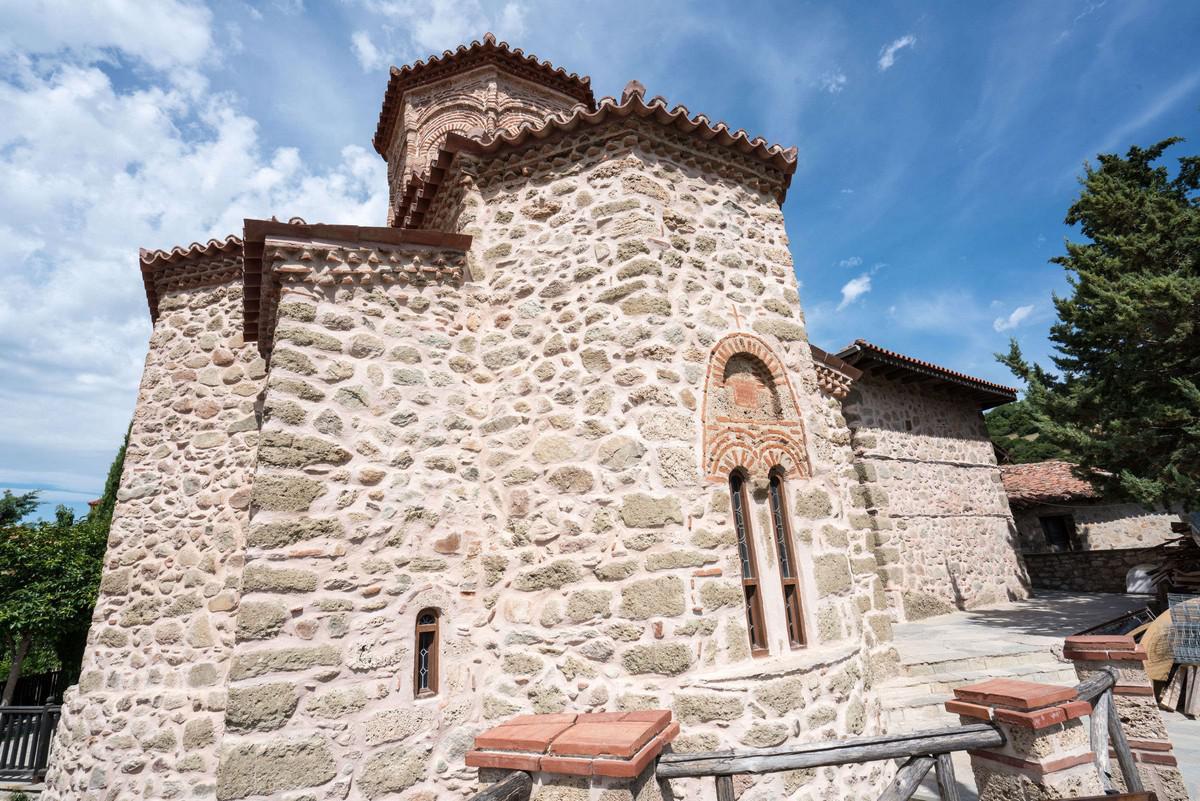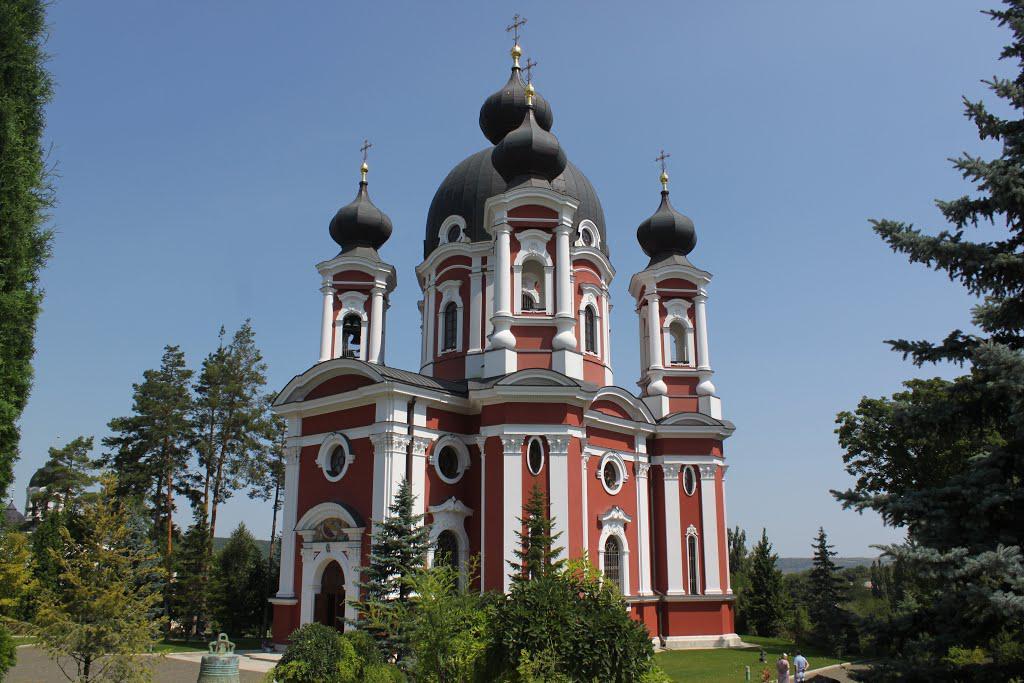The first image is the image on the left, the second image is the image on the right. Examine the images to the left and right. Is the description "In one image, a large building is red with white trim and a black decorative rooftop." accurate? Answer yes or no. Yes. The first image is the image on the left, the second image is the image on the right. Analyze the images presented: Is the assertion "One image shows a building topped with multiple dark gray onion-shapes with crosses on top." valid? Answer yes or no. Yes. 